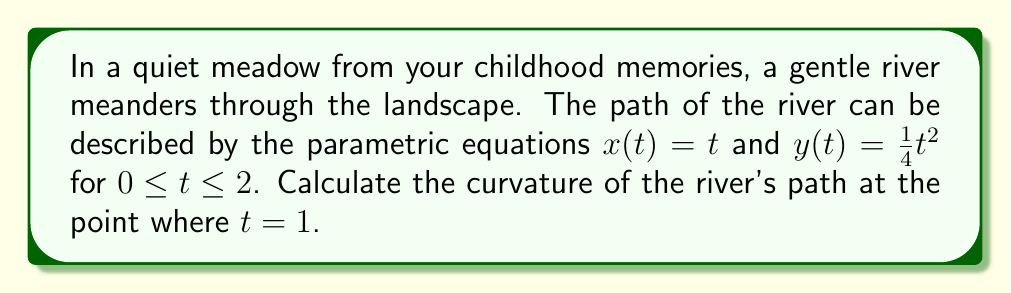What is the answer to this math problem? Let's approach this step-by-step:

1) The curvature $\kappa$ of a curve given by parametric equations $x(t)$ and $y(t)$ is given by the formula:

   $$\kappa = \frac{|x'y'' - y'x''|}{(x'^2 + y'^2)^{3/2}}$$

2) We need to find $x'$, $y'$, $x''$, and $y''$:
   
   $x' = \frac{dx}{dt} = 1$
   $y' = \frac{dy}{dt} = \frac{1}{2}t$
   $x'' = \frac{d^2x}{dt^2} = 0$
   $y'' = \frac{d^2y}{dt^2} = \frac{1}{2}$

3) Now, let's substitute these into our curvature formula:

   $$\kappa = \frac{|1 \cdot \frac{1}{2} - \frac{1}{2}t \cdot 0|}{(1^2 + (\frac{1}{2}t)^2)^{3/2}}$$

4) Simplify:

   $$\kappa = \frac{\frac{1}{2}}{(1 + \frac{1}{4}t^2)^{3/2}}$$

5) We're asked to find the curvature at $t = 1$, so let's substitute this:

   $$\kappa = \frac{\frac{1}{2}}{(1 + \frac{1}{4})^{3/2}} = \frac{\frac{1}{2}}{(\frac{5}{4})^{3/2}}$$

6) Simplify:

   $$\kappa = \frac{\frac{1}{2}}{\frac{5\sqrt{5}}{8}} = \frac{4}{5\sqrt{5}}$$

This gives us the curvature of the river's path at the point where $t = 1$.
Answer: $\frac{4}{5\sqrt{5}}$ 